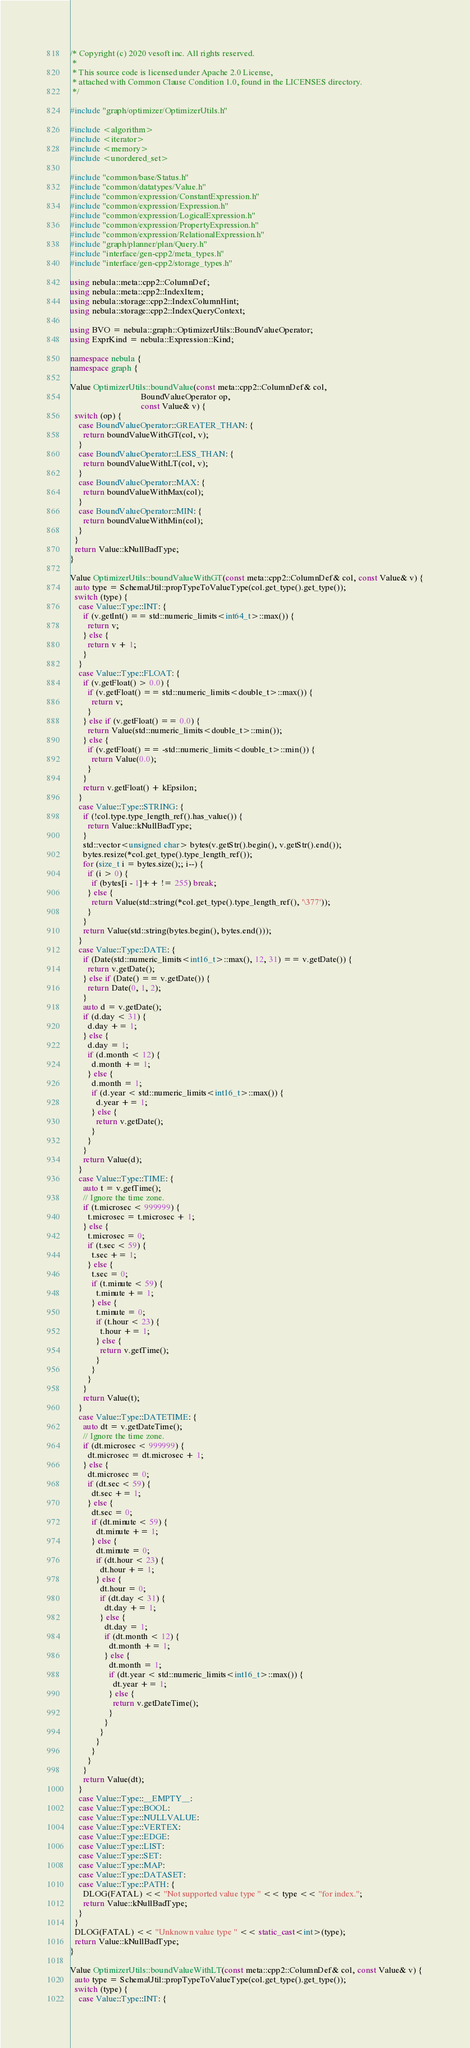Convert code to text. <code><loc_0><loc_0><loc_500><loc_500><_C++_>/* Copyright (c) 2020 vesoft inc. All rights reserved.
 *
 * This source code is licensed under Apache 2.0 License,
 * attached with Common Clause Condition 1.0, found in the LICENSES directory.
 */

#include "graph/optimizer/OptimizerUtils.h"

#include <algorithm>
#include <iterator>
#include <memory>
#include <unordered_set>

#include "common/base/Status.h"
#include "common/datatypes/Value.h"
#include "common/expression/ConstantExpression.h"
#include "common/expression/Expression.h"
#include "common/expression/LogicalExpression.h"
#include "common/expression/PropertyExpression.h"
#include "common/expression/RelationalExpression.h"
#include "graph/planner/plan/Query.h"
#include "interface/gen-cpp2/meta_types.h"
#include "interface/gen-cpp2/storage_types.h"

using nebula::meta::cpp2::ColumnDef;
using nebula::meta::cpp2::IndexItem;
using nebula::storage::cpp2::IndexColumnHint;
using nebula::storage::cpp2::IndexQueryContext;

using BVO = nebula::graph::OptimizerUtils::BoundValueOperator;
using ExprKind = nebula::Expression::Kind;

namespace nebula {
namespace graph {

Value OptimizerUtils::boundValue(const meta::cpp2::ColumnDef& col,
                                 BoundValueOperator op,
                                 const Value& v) {
  switch (op) {
    case BoundValueOperator::GREATER_THAN: {
      return boundValueWithGT(col, v);
    }
    case BoundValueOperator::LESS_THAN: {
      return boundValueWithLT(col, v);
    }
    case BoundValueOperator::MAX: {
      return boundValueWithMax(col);
    }
    case BoundValueOperator::MIN: {
      return boundValueWithMin(col);
    }
  }
  return Value::kNullBadType;
}

Value OptimizerUtils::boundValueWithGT(const meta::cpp2::ColumnDef& col, const Value& v) {
  auto type = SchemaUtil::propTypeToValueType(col.get_type().get_type());
  switch (type) {
    case Value::Type::INT: {
      if (v.getInt() == std::numeric_limits<int64_t>::max()) {
        return v;
      } else {
        return v + 1;
      }
    }
    case Value::Type::FLOAT: {
      if (v.getFloat() > 0.0) {
        if (v.getFloat() == std::numeric_limits<double_t>::max()) {
          return v;
        }
      } else if (v.getFloat() == 0.0) {
        return Value(std::numeric_limits<double_t>::min());
      } else {
        if (v.getFloat() == -std::numeric_limits<double_t>::min()) {
          return Value(0.0);
        }
      }
      return v.getFloat() + kEpsilon;
    }
    case Value::Type::STRING: {
      if (!col.type.type_length_ref().has_value()) {
        return Value::kNullBadType;
      }
      std::vector<unsigned char> bytes(v.getStr().begin(), v.getStr().end());
      bytes.resize(*col.get_type().type_length_ref());
      for (size_t i = bytes.size();; i--) {
        if (i > 0) {
          if (bytes[i - 1]++ != 255) break;
        } else {
          return Value(std::string(*col.get_type().type_length_ref(), '\377'));
        }
      }
      return Value(std::string(bytes.begin(), bytes.end()));
    }
    case Value::Type::DATE: {
      if (Date(std::numeric_limits<int16_t>::max(), 12, 31) == v.getDate()) {
        return v.getDate();
      } else if (Date() == v.getDate()) {
        return Date(0, 1, 2);
      }
      auto d = v.getDate();
      if (d.day < 31) {
        d.day += 1;
      } else {
        d.day = 1;
        if (d.month < 12) {
          d.month += 1;
        } else {
          d.month = 1;
          if (d.year < std::numeric_limits<int16_t>::max()) {
            d.year += 1;
          } else {
            return v.getDate();
          }
        }
      }
      return Value(d);
    }
    case Value::Type::TIME: {
      auto t = v.getTime();
      // Ignore the time zone.
      if (t.microsec < 999999) {
        t.microsec = t.microsec + 1;
      } else {
        t.microsec = 0;
        if (t.sec < 59) {
          t.sec += 1;
        } else {
          t.sec = 0;
          if (t.minute < 59) {
            t.minute += 1;
          } else {
            t.minute = 0;
            if (t.hour < 23) {
              t.hour += 1;
            } else {
              return v.getTime();
            }
          }
        }
      }
      return Value(t);
    }
    case Value::Type::DATETIME: {
      auto dt = v.getDateTime();
      // Ignore the time zone.
      if (dt.microsec < 999999) {
        dt.microsec = dt.microsec + 1;
      } else {
        dt.microsec = 0;
        if (dt.sec < 59) {
          dt.sec += 1;
        } else {
          dt.sec = 0;
          if (dt.minute < 59) {
            dt.minute += 1;
          } else {
            dt.minute = 0;
            if (dt.hour < 23) {
              dt.hour += 1;
            } else {
              dt.hour = 0;
              if (dt.day < 31) {
                dt.day += 1;
              } else {
                dt.day = 1;
                if (dt.month < 12) {
                  dt.month += 1;
                } else {
                  dt.month = 1;
                  if (dt.year < std::numeric_limits<int16_t>::max()) {
                    dt.year += 1;
                  } else {
                    return v.getDateTime();
                  }
                }
              }
            }
          }
        }
      }
      return Value(dt);
    }
    case Value::Type::__EMPTY__:
    case Value::Type::BOOL:
    case Value::Type::NULLVALUE:
    case Value::Type::VERTEX:
    case Value::Type::EDGE:
    case Value::Type::LIST:
    case Value::Type::SET:
    case Value::Type::MAP:
    case Value::Type::DATASET:
    case Value::Type::PATH: {
      DLOG(FATAL) << "Not supported value type " << type << "for index.";
      return Value::kNullBadType;
    }
  }
  DLOG(FATAL) << "Unknown value type " << static_cast<int>(type);
  return Value::kNullBadType;
}

Value OptimizerUtils::boundValueWithLT(const meta::cpp2::ColumnDef& col, const Value& v) {
  auto type = SchemaUtil::propTypeToValueType(col.get_type().get_type());
  switch (type) {
    case Value::Type::INT: {</code> 